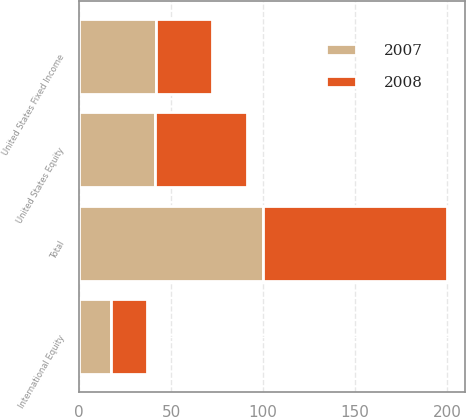Convert chart. <chart><loc_0><loc_0><loc_500><loc_500><stacked_bar_chart><ecel><fcel>United States Fixed Income<fcel>United States Equity<fcel>International Equity<fcel>Total<nl><fcel>2007<fcel>42<fcel>41<fcel>17<fcel>100<nl><fcel>2008<fcel>30<fcel>50<fcel>20<fcel>100<nl></chart> 